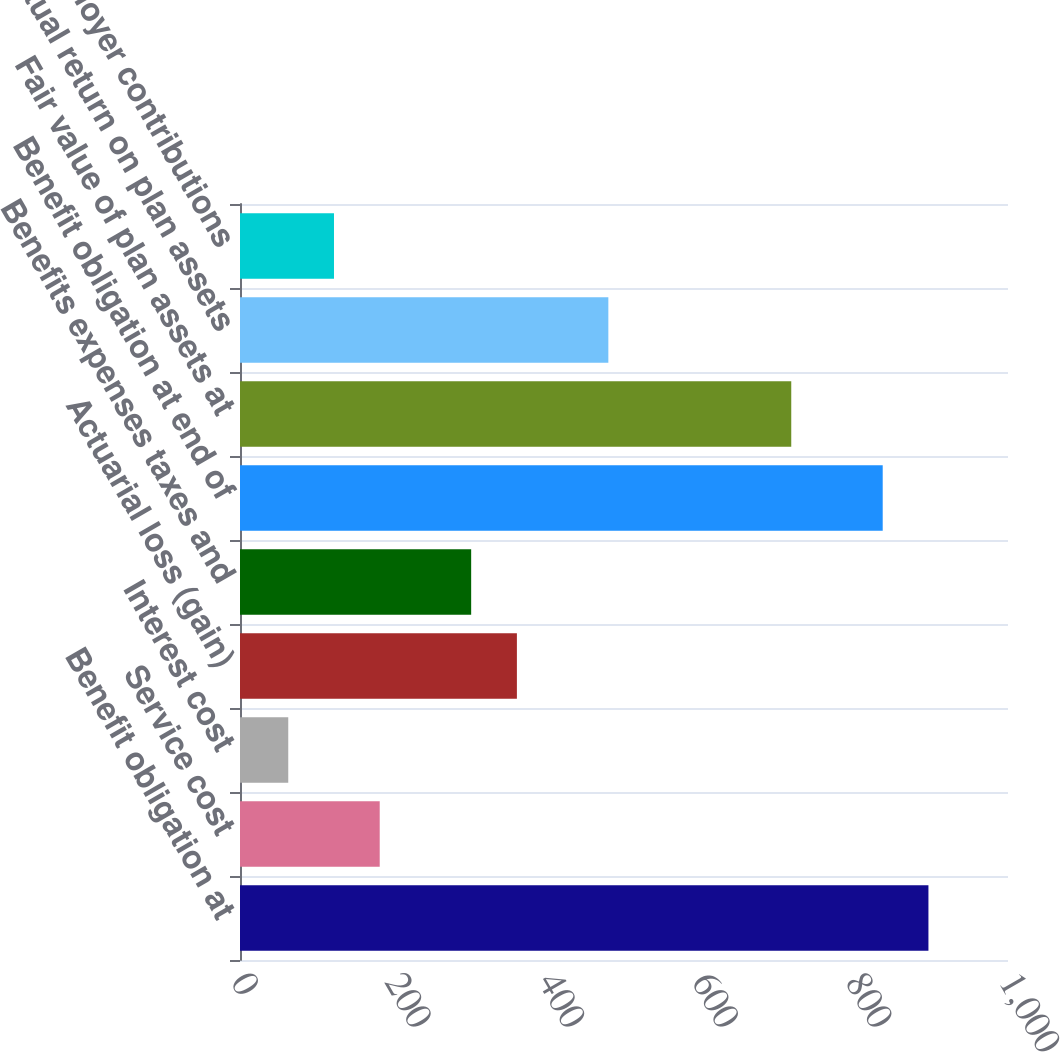Convert chart to OTSL. <chart><loc_0><loc_0><loc_500><loc_500><bar_chart><fcel>Benefit obligation at<fcel>Service cost<fcel>Interest cost<fcel>Actuarial loss (gain)<fcel>Benefits expenses taxes and<fcel>Benefit obligation at end of<fcel>Fair value of plan assets at<fcel>Actual return on plan assets<fcel>Employer contributions<nl><fcel>896.4<fcel>181.92<fcel>62.84<fcel>360.54<fcel>301<fcel>836.86<fcel>717.78<fcel>479.62<fcel>122.38<nl></chart> 